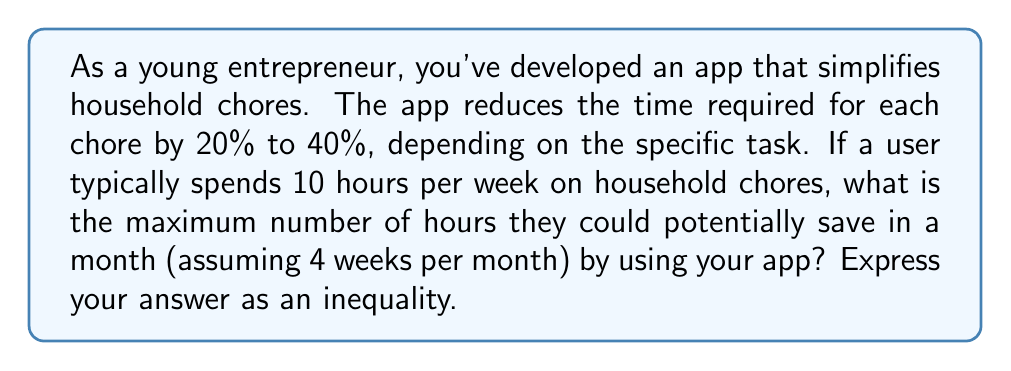Give your solution to this math problem. Let's approach this step-by-step:

1) First, we need to calculate the total time spent on chores in a month:
   $10 \text{ hours/week} \times 4 \text{ weeks} = 40 \text{ hours/month}$

2) The app reduces time by 20% to 40%. To find the maximum time savings, we'll use the upper limit of 40%.

3) To calculate the maximum time saved, we need to find 40% of 40 hours:
   $$40\% \text{ of } 40 \text{ hours} = 0.40 \times 40 \text{ hours} = 16 \text{ hours}$$

4) However, we need to express this as an inequality. Since the time savings can be up to 40%, but not more, we can express this as:

   $$0 \leq \text{Time Saved} \leq 16$$

   This inequality states that the time saved is greater than or equal to 0 hours (as the app can't increase the time spent on chores) and less than or equal to 16 hours (the maximum possible savings).

5) We can also express this in terms of hours saved per week:
   $$0 \leq \text{Time Saved per Week} \leq 4$$

   Since $16 \text{ hours/month} \div 4 \text{ weeks/month} = 4 \text{ hours/week}$
Answer: $0 \leq \text{Time Saved} \leq 16$ hours per month, or equivalently, $0 \leq \text{Time Saved per Week} \leq 4$ hours 